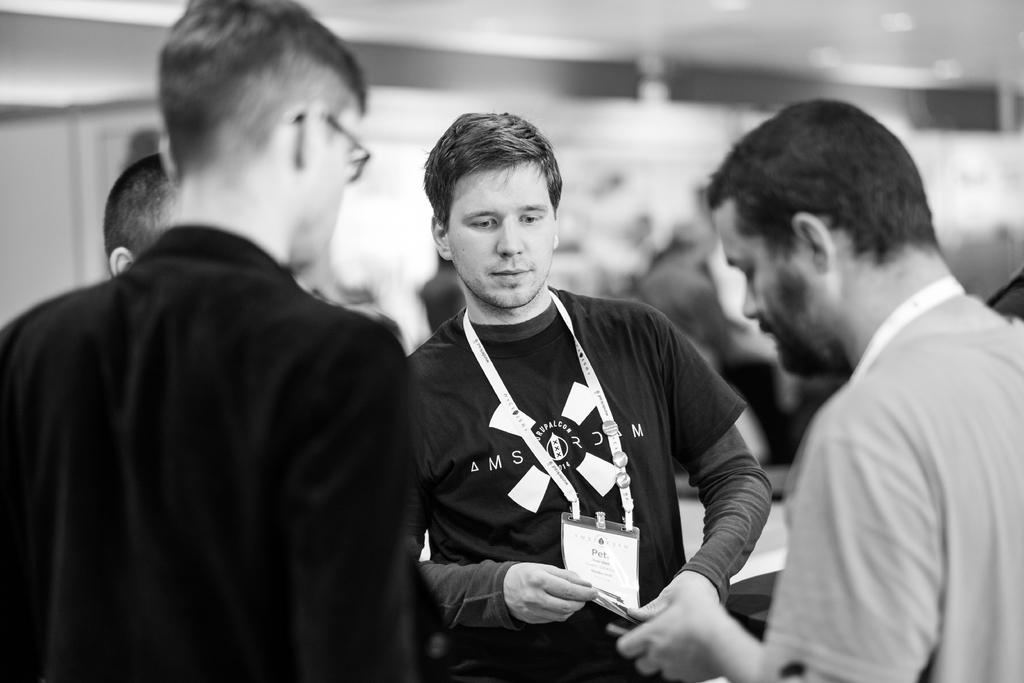What is happening in the image? There are people standing in the image. Can you describe any specific actions or objects being held by the people? Yes, there is a person holding an ID card, and there is a person on the right side of the image holding something in his hand. What type of guitar is the person on the left side of the image playing? There is no guitar present in the image; the person is holding an ID card. 